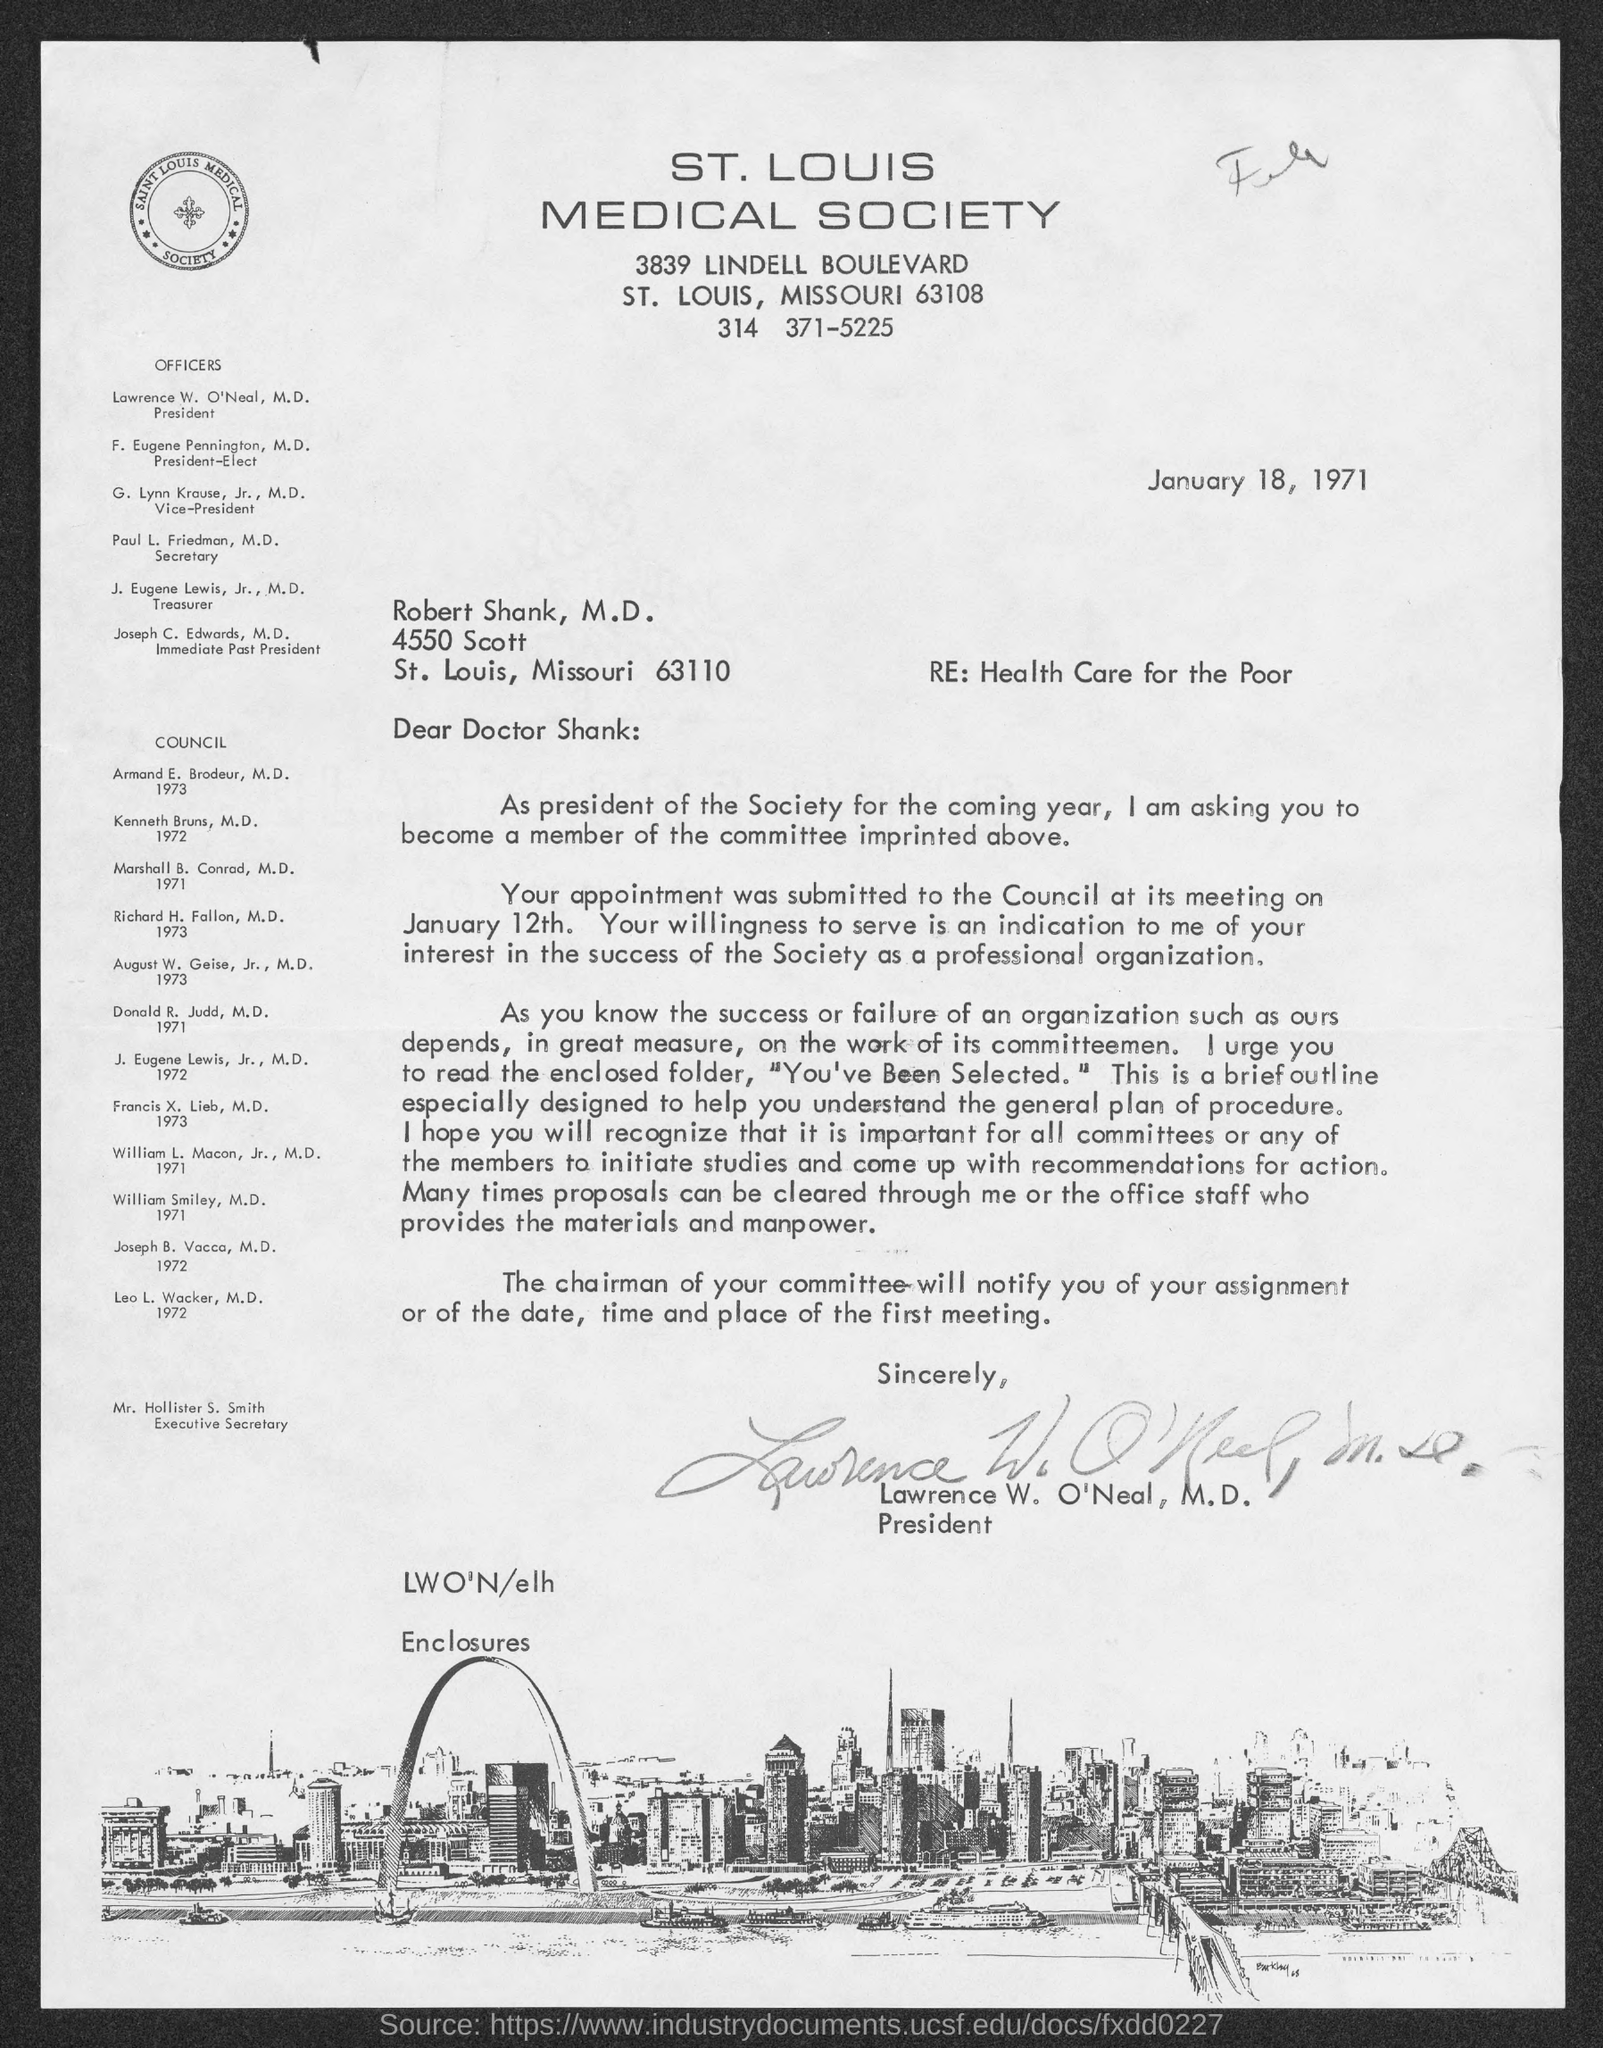Which society is mentioned?
Provide a short and direct response. St. Louis Medical Society. When is the letter dated?
Ensure brevity in your answer.  January 18, 1971. To whom is the letter addressed?
Provide a succinct answer. Doctor Shank. Who is the President?
Give a very brief answer. Lawrence W. O'Neal, M.D. Who is the secretary?
Keep it short and to the point. Paul L. Friedman. When was the appointment submitted to the Council?
Make the answer very short. At its meeting on january 12th. What is the designation of Mr. Hollister S. Smith?
Your answer should be compact. Executive Secretary. 